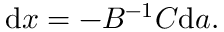<formula> <loc_0><loc_0><loc_500><loc_500>{ d } x = - B ^ { - 1 } C { d } a .</formula> 